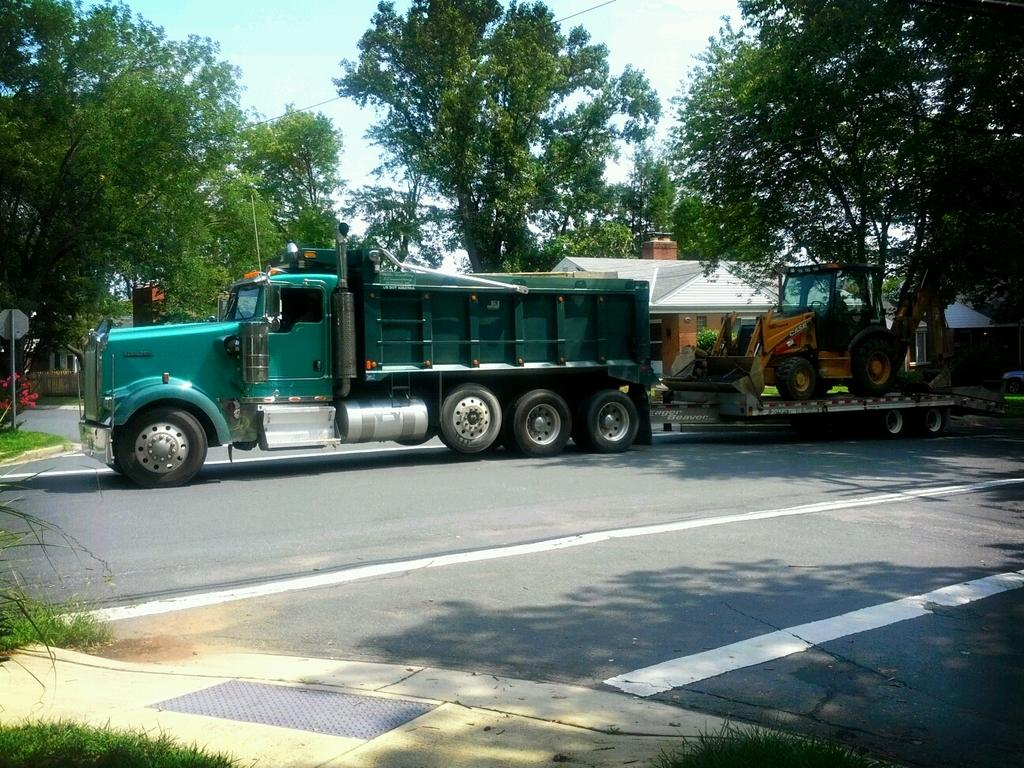What type of vehicle is on the road in the image? There is a load vehicle on the road in the image. What can be seen in the background of the image? There is a house and many trees in the background of the image. Where is the sign board located in the image? The sign board is in the left side of the image. What is present in the left side of the image besides the sign board? There is a flower plant in the left side of the image. What is visible at the top of the image? The sky is visible at the top of the image. What type of development has the achiever made in the image? There is no reference to an achiever or any development in the image; it features a load vehicle on the road, a house and trees in the background, a sign board and a flower plant on the left side, and a visible sky. 